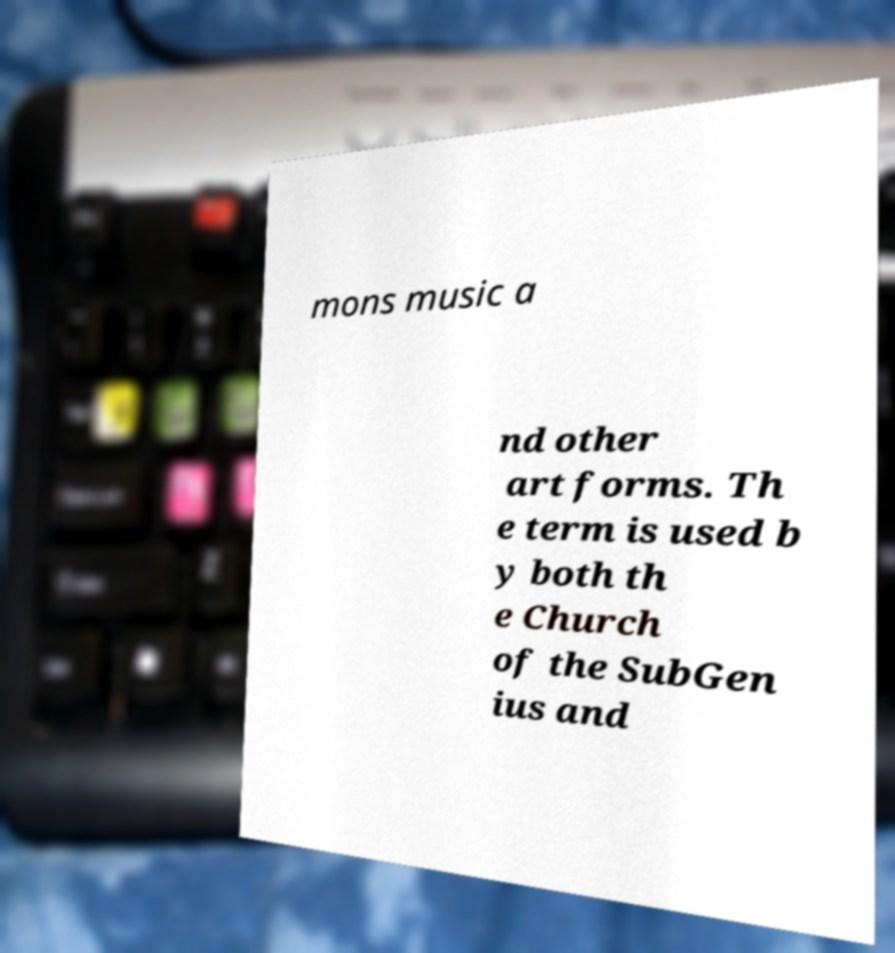Could you assist in decoding the text presented in this image and type it out clearly? mons music a nd other art forms. Th e term is used b y both th e Church of the SubGen ius and 